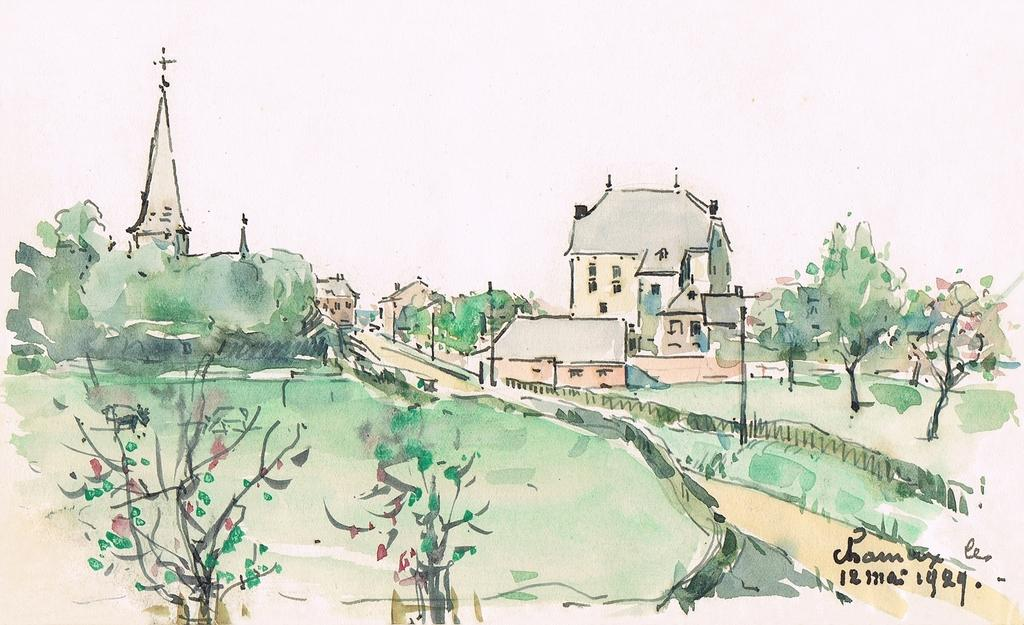What type of natural elements are present in the painting? The painting contains trees, plants, and flowers. What type of man-made structures are present in the painting? The painting contains a church and houses. What is the color of the top part of the painting? The top part of the painting is white in color. Can you see a smile on any of the flowers in the painting? There are no smiles depicted on the flowers or any other elements in the painting. What type of calculator is present in the painting? There is no calculator present in the painting. 